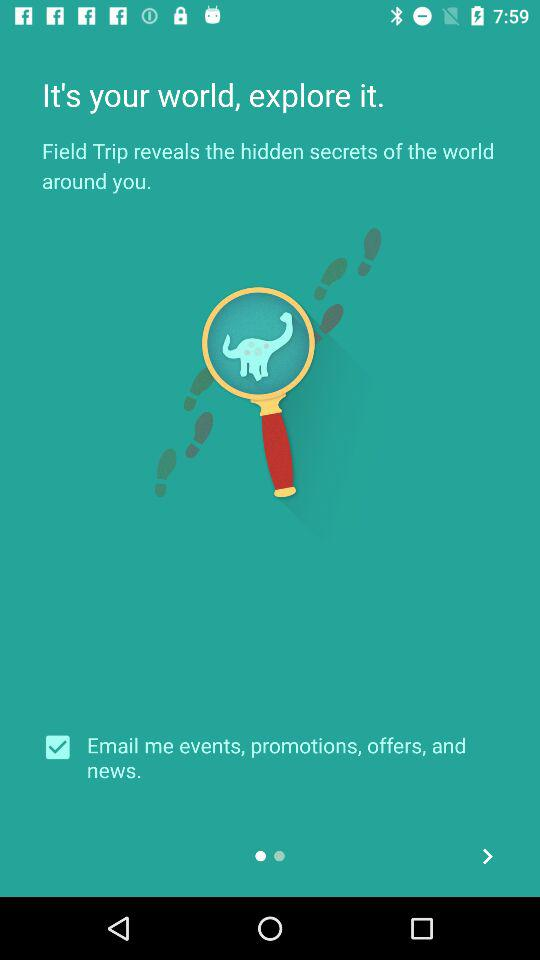Who is getting emails from the application?
When the provided information is insufficient, respond with <no answer>. <no answer> 